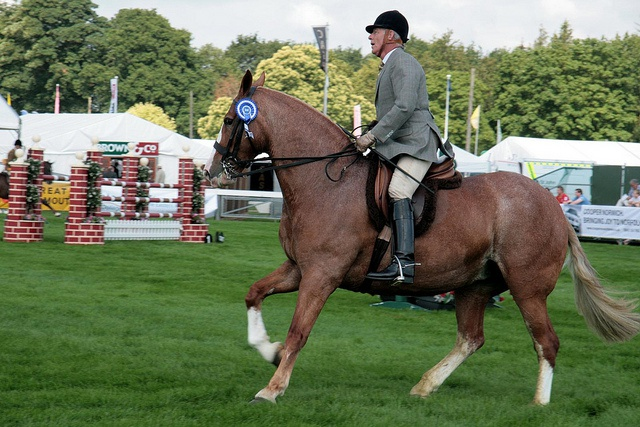Describe the objects in this image and their specific colors. I can see horse in lightgray, gray, black, and maroon tones, people in lightgray, gray, black, and darkgray tones, people in lightgray, darkgray, lightpink, and gray tones, people in lightgray, brown, darkgray, gray, and lightpink tones, and people in lightgray, darkgray, and gray tones in this image. 